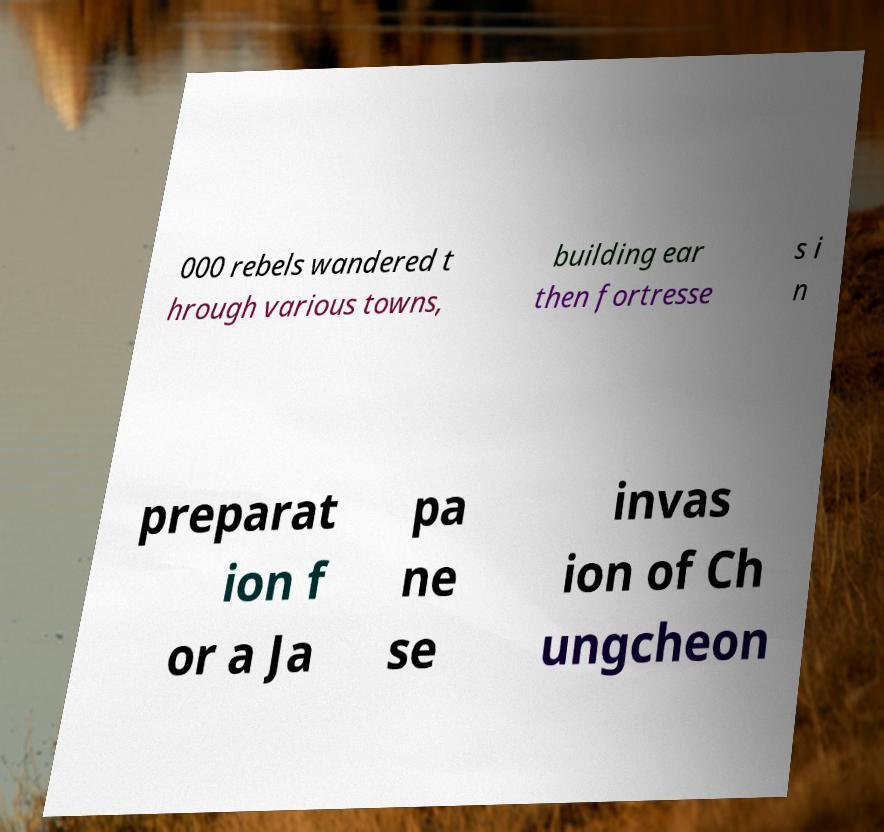Could you assist in decoding the text presented in this image and type it out clearly? 000 rebels wandered t hrough various towns, building ear then fortresse s i n preparat ion f or a Ja pa ne se invas ion of Ch ungcheon 